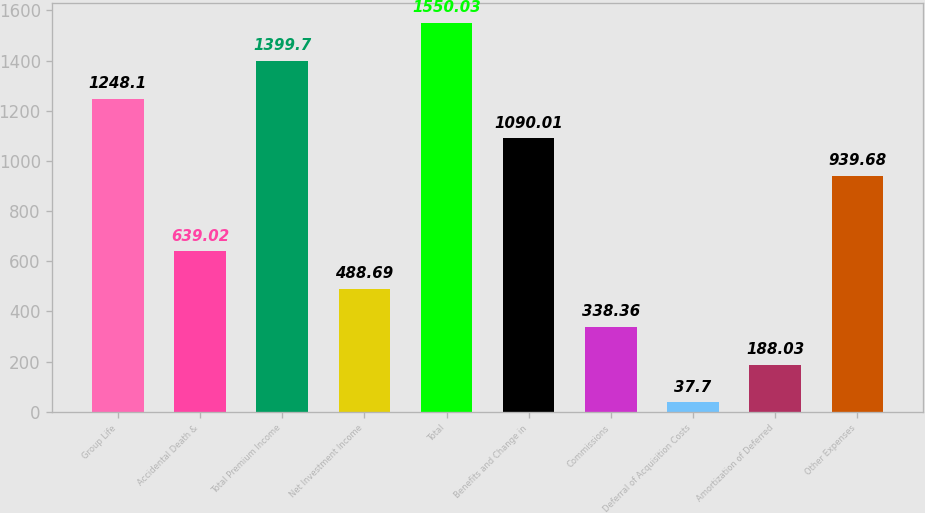Convert chart to OTSL. <chart><loc_0><loc_0><loc_500><loc_500><bar_chart><fcel>Group Life<fcel>Accidental Death &<fcel>Total Premium Income<fcel>Net Investment Income<fcel>Total<fcel>Benefits and Change in<fcel>Commissions<fcel>Deferral of Acquisition Costs<fcel>Amortization of Deferred<fcel>Other Expenses<nl><fcel>1248.1<fcel>639.02<fcel>1399.7<fcel>488.69<fcel>1550.03<fcel>1090.01<fcel>338.36<fcel>37.7<fcel>188.03<fcel>939.68<nl></chart> 